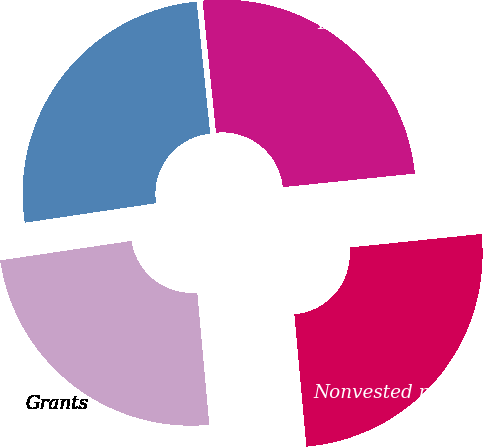Convert chart. <chart><loc_0><loc_0><loc_500><loc_500><pie_chart><fcel>Nonvested restricted shares at<fcel>Grants<fcel>Vested<fcel>Forfeited<nl><fcel>25.19%<fcel>24.09%<fcel>25.73%<fcel>24.99%<nl></chart> 